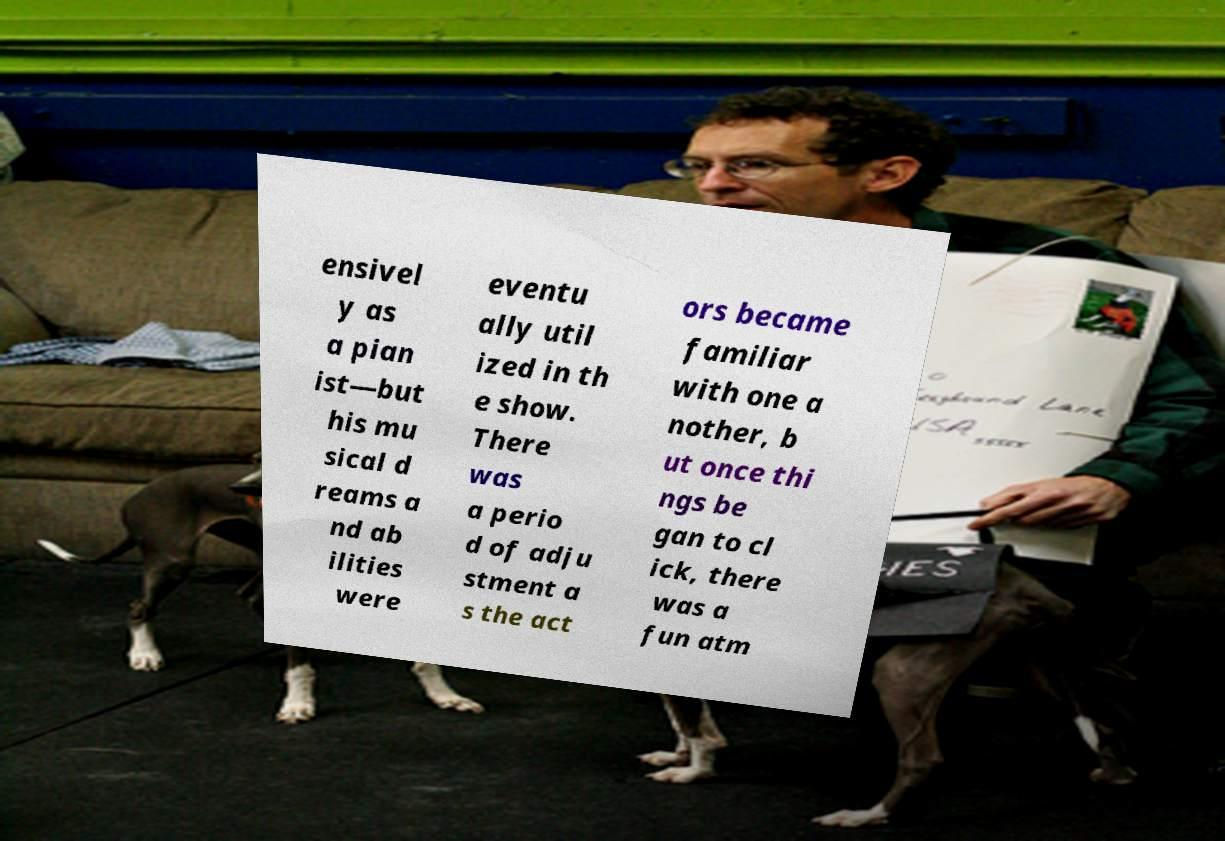Can you read and provide the text displayed in the image?This photo seems to have some interesting text. Can you extract and type it out for me? ensivel y as a pian ist—but his mu sical d reams a nd ab ilities were eventu ally util ized in th e show. There was a perio d of adju stment a s the act ors became familiar with one a nother, b ut once thi ngs be gan to cl ick, there was a fun atm 